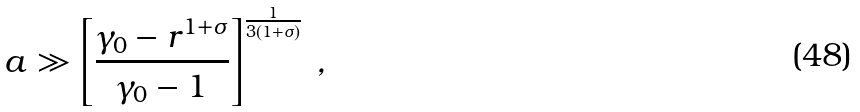Convert formula to latex. <formula><loc_0><loc_0><loc_500><loc_500>a \gg \left [ \frac { \gamma _ { 0 } - r ^ { 1 + \sigma } } { \gamma _ { 0 } - 1 } \right ] ^ { \frac { 1 } { 3 ( 1 + \sigma ) } } \, ,</formula> 